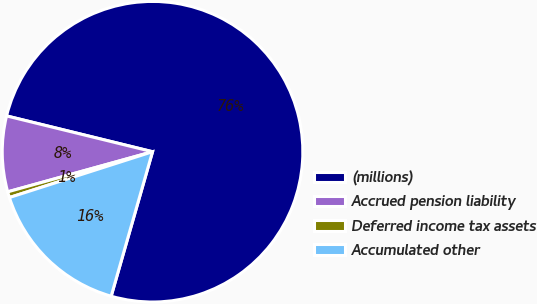Convert chart to OTSL. <chart><loc_0><loc_0><loc_500><loc_500><pie_chart><fcel>(millions)<fcel>Accrued pension liability<fcel>Deferred income tax assets<fcel>Accumulated other<nl><fcel>75.61%<fcel>8.13%<fcel>0.63%<fcel>15.63%<nl></chart> 